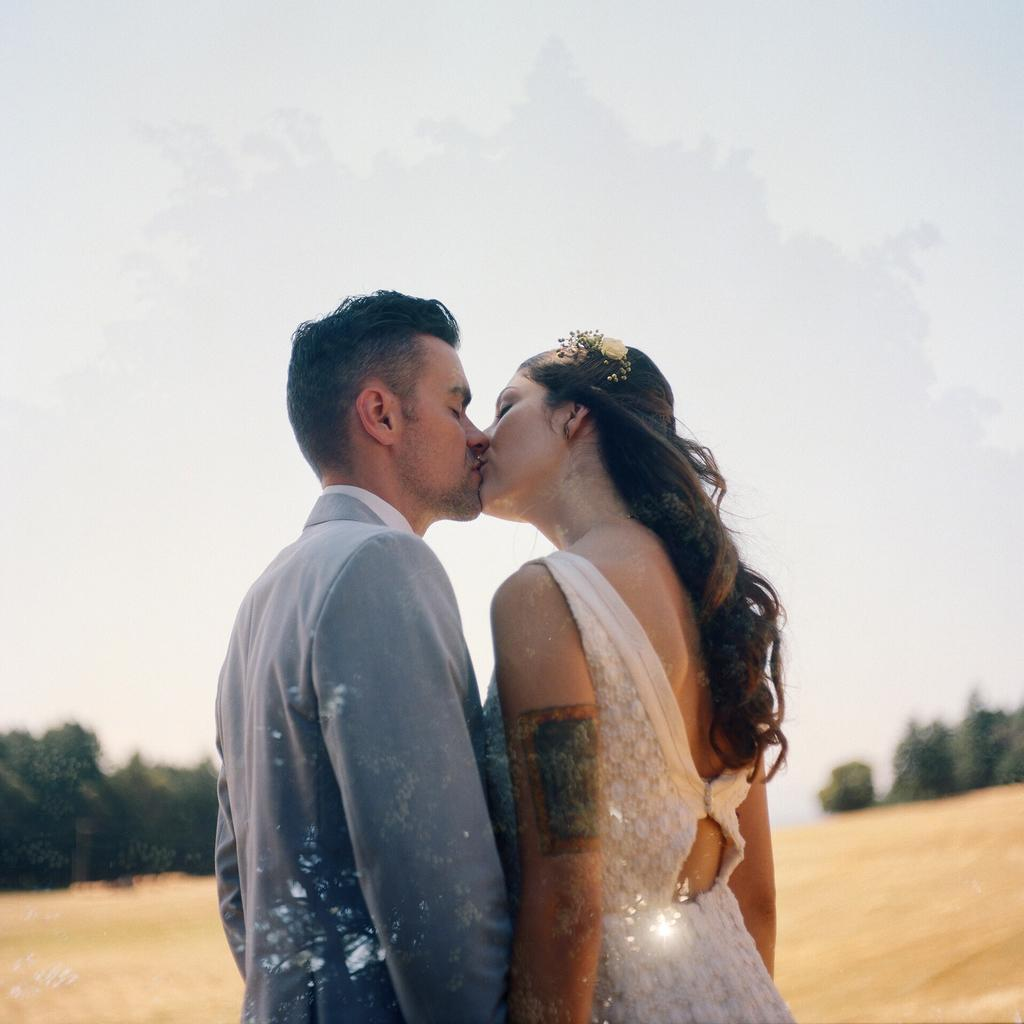Who are the people in the center of the image? There is a man and a woman in the center of the image. What can be seen in the background of the image? There are trees, the ground, and the sky visible in the background of the image. What type of apple is the man holding in the image? There is no apple present in the image. What color is the shirt the woman is wearing in the image? The provided facts do not mention the color of the woman's shirt, so we cannot determine the color from the image. 